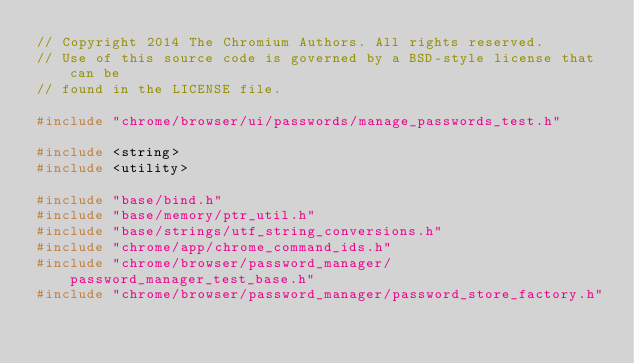<code> <loc_0><loc_0><loc_500><loc_500><_C++_>// Copyright 2014 The Chromium Authors. All rights reserved.
// Use of this source code is governed by a BSD-style license that can be
// found in the LICENSE file.

#include "chrome/browser/ui/passwords/manage_passwords_test.h"

#include <string>
#include <utility>

#include "base/bind.h"
#include "base/memory/ptr_util.h"
#include "base/strings/utf_string_conversions.h"
#include "chrome/app/chrome_command_ids.h"
#include "chrome/browser/password_manager/password_manager_test_base.h"
#include "chrome/browser/password_manager/password_store_factory.h"</code> 